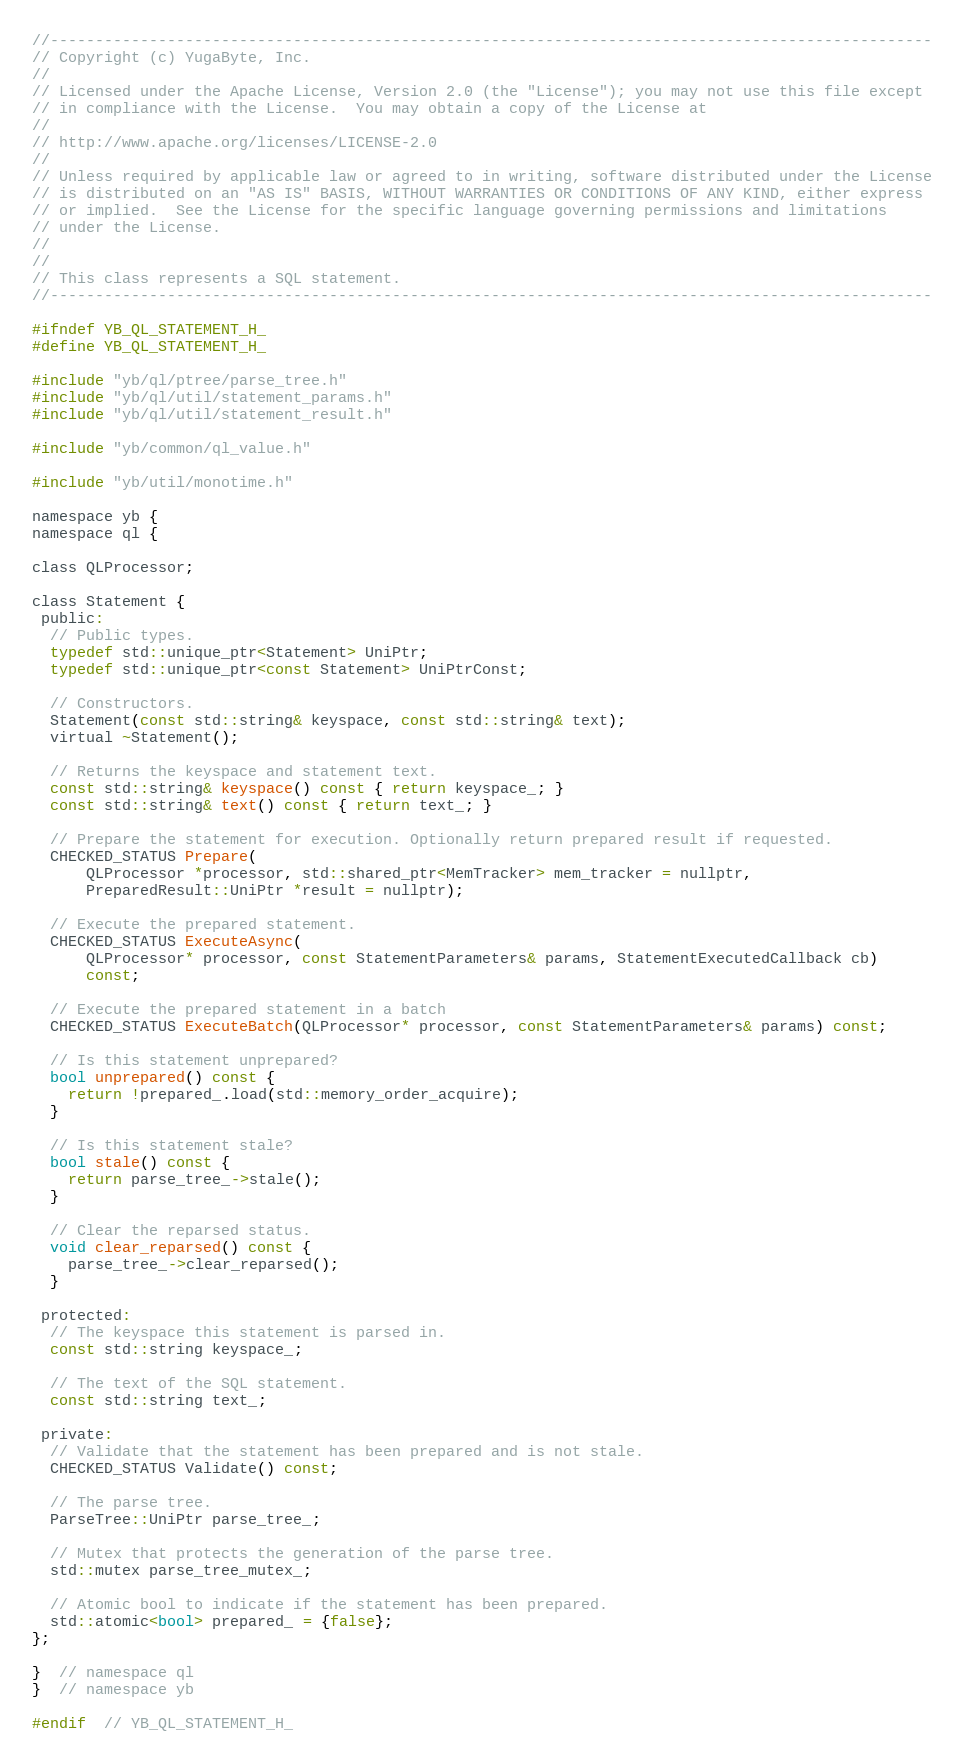<code> <loc_0><loc_0><loc_500><loc_500><_C_>//--------------------------------------------------------------------------------------------------
// Copyright (c) YugaByte, Inc.
//
// Licensed under the Apache License, Version 2.0 (the "License"); you may not use this file except
// in compliance with the License.  You may obtain a copy of the License at
//
// http://www.apache.org/licenses/LICENSE-2.0
//
// Unless required by applicable law or agreed to in writing, software distributed under the License
// is distributed on an "AS IS" BASIS, WITHOUT WARRANTIES OR CONDITIONS OF ANY KIND, either express
// or implied.  See the License for the specific language governing permissions and limitations
// under the License.
//
//
// This class represents a SQL statement.
//--------------------------------------------------------------------------------------------------

#ifndef YB_QL_STATEMENT_H_
#define YB_QL_STATEMENT_H_

#include "yb/ql/ptree/parse_tree.h"
#include "yb/ql/util/statement_params.h"
#include "yb/ql/util/statement_result.h"

#include "yb/common/ql_value.h"

#include "yb/util/monotime.h"

namespace yb {
namespace ql {

class QLProcessor;

class Statement {
 public:
  // Public types.
  typedef std::unique_ptr<Statement> UniPtr;
  typedef std::unique_ptr<const Statement> UniPtrConst;

  // Constructors.
  Statement(const std::string& keyspace, const std::string& text);
  virtual ~Statement();

  // Returns the keyspace and statement text.
  const std::string& keyspace() const { return keyspace_; }
  const std::string& text() const { return text_; }

  // Prepare the statement for execution. Optionally return prepared result if requested.
  CHECKED_STATUS Prepare(
      QLProcessor *processor, std::shared_ptr<MemTracker> mem_tracker = nullptr,
      PreparedResult::UniPtr *result = nullptr);

  // Execute the prepared statement.
  CHECKED_STATUS ExecuteAsync(
      QLProcessor* processor, const StatementParameters& params, StatementExecutedCallback cb)
      const;

  // Execute the prepared statement in a batch
  CHECKED_STATUS ExecuteBatch(QLProcessor* processor, const StatementParameters& params) const;

  // Is this statement unprepared?
  bool unprepared() const {
    return !prepared_.load(std::memory_order_acquire);
  }

  // Is this statement stale?
  bool stale() const {
    return parse_tree_->stale();
  }

  // Clear the reparsed status.
  void clear_reparsed() const {
    parse_tree_->clear_reparsed();
  }

 protected:
  // The keyspace this statement is parsed in.
  const std::string keyspace_;

  // The text of the SQL statement.
  const std::string text_;

 private:
  // Validate that the statement has been prepared and is not stale.
  CHECKED_STATUS Validate() const;

  // The parse tree.
  ParseTree::UniPtr parse_tree_;

  // Mutex that protects the generation of the parse tree.
  std::mutex parse_tree_mutex_;

  // Atomic bool to indicate if the statement has been prepared.
  std::atomic<bool> prepared_ = {false};
};

}  // namespace ql
}  // namespace yb

#endif  // YB_QL_STATEMENT_H_
</code> 